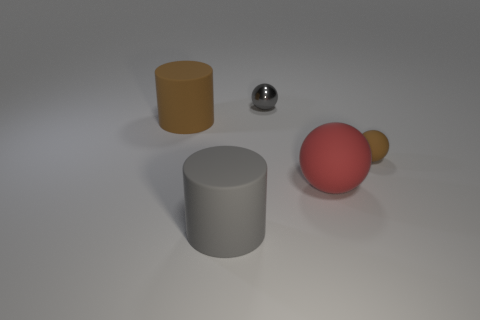Subtract all rubber balls. How many balls are left? 1 Add 1 shiny balls. How many objects exist? 6 Subtract all cyan spheres. Subtract all yellow blocks. How many spheres are left? 3 Subtract all cylinders. How many objects are left? 3 Add 1 red matte objects. How many red matte objects exist? 2 Subtract 0 green spheres. How many objects are left? 5 Subtract all gray cylinders. Subtract all small objects. How many objects are left? 2 Add 4 large red matte balls. How many large red matte balls are left? 5 